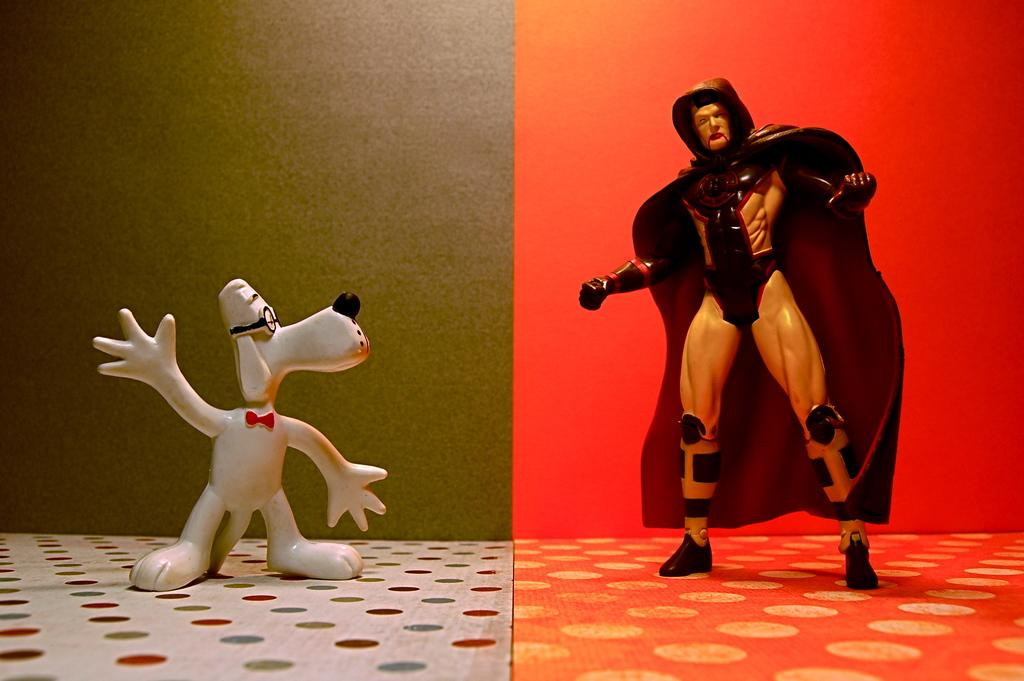What type of artwork is depicted in the image? The image appears to be a collage. What can be seen on the left side of the collage? There is a toy standing on the left side of the image. What can be seen on the right side of the collage? There is another toy standing on the right side of the image. What colors are used for the background on the left and right sides of the collage? The background on the left side of the image is red, and the background on the right side of the image is green. What type of protest is taking place in the image? There is no protest depicted in the image; it is a collage featuring two toys and different background colors. What is the scale of the toys in the image? The scale of the toys cannot be determined from the image alone, as there is no reference point for comparison. 